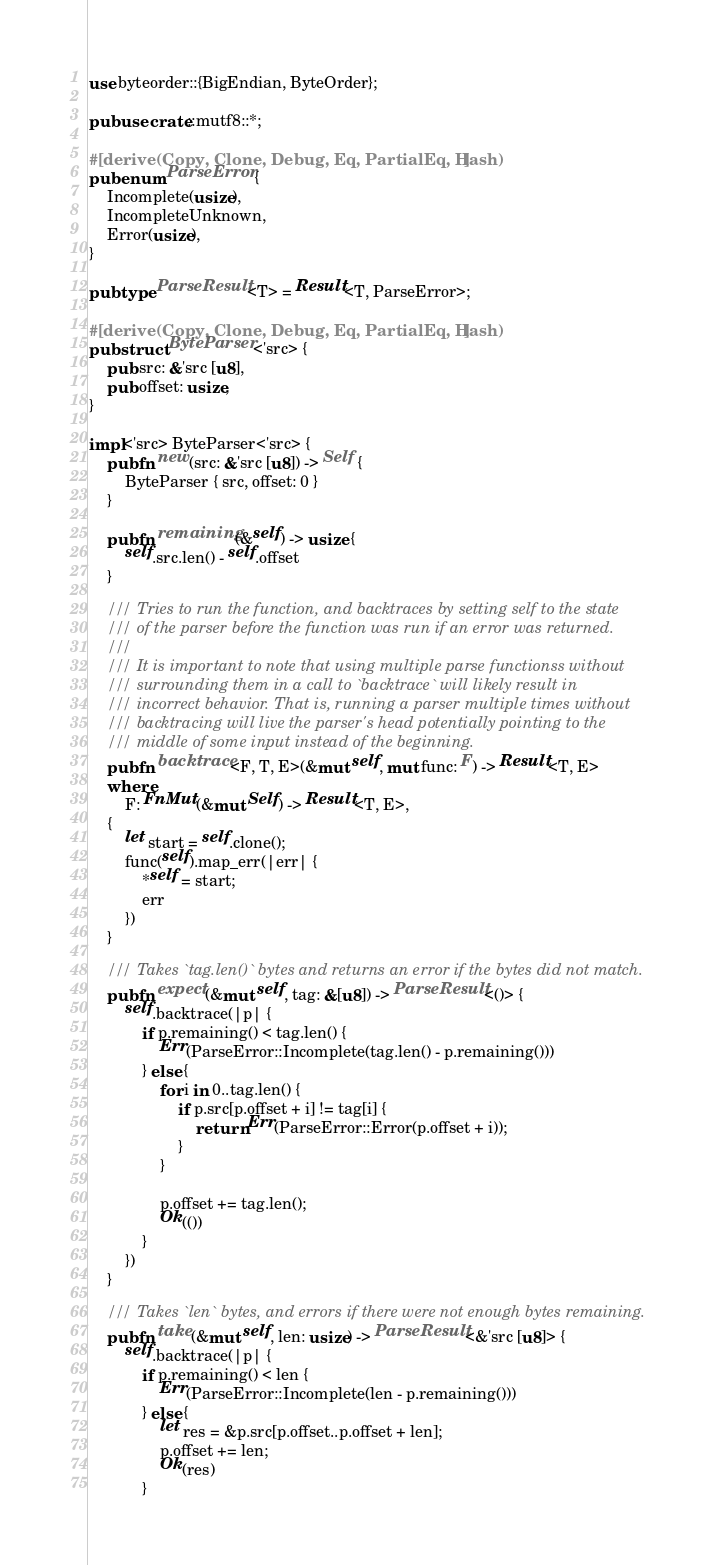<code> <loc_0><loc_0><loc_500><loc_500><_Rust_>use byteorder::{BigEndian, ByteOrder};

pub use crate::mutf8::*;

#[derive(Copy, Clone, Debug, Eq, PartialEq, Hash)]
pub enum ParseError {
    Incomplete(usize),
    IncompleteUnknown,
    Error(usize),
}

pub type ParseResult<T> = Result<T, ParseError>;

#[derive(Copy, Clone, Debug, Eq, PartialEq, Hash)]
pub struct ByteParser<'src> {
    pub src: &'src [u8],
    pub offset: usize,
}

impl<'src> ByteParser<'src> {
    pub fn new(src: &'src [u8]) -> Self {
        ByteParser { src, offset: 0 }
    }

    pub fn remaining(&self) -> usize {
        self.src.len() - self.offset
    }

    /// Tries to run the function, and backtraces by setting self to the state
    /// of the parser before the function was run if an error was returned.
    ///
    /// It is important to note that using multiple parse functionss without
    /// surrounding them in a call to `backtrace` will likely result in
    /// incorrect behavior. That is, running a parser multiple times without
    /// backtracing will live the parser's head potentially pointing to the
    /// middle of some input instead of the beginning.
    pub fn backtrace<F, T, E>(&mut self, mut func: F) -> Result<T, E>
    where
        F: FnMut(&mut Self) -> Result<T, E>,
    {
        let start = self.clone();
        func(self).map_err(|err| {
            *self = start;
            err
        })
    }

    /// Takes `tag.len()` bytes and returns an error if the bytes did not match.
    pub fn expect(&mut self, tag: &[u8]) -> ParseResult<()> {
        self.backtrace(|p| {
            if p.remaining() < tag.len() {
                Err(ParseError::Incomplete(tag.len() - p.remaining()))
            } else {
                for i in 0..tag.len() {
                    if p.src[p.offset + i] != tag[i] {
                        return Err(ParseError::Error(p.offset + i));
                    }
                }

                p.offset += tag.len();
                Ok(())
            }
        })
    }

    /// Takes `len` bytes, and errors if there were not enough bytes remaining.
    pub fn take(&mut self, len: usize) -> ParseResult<&'src [u8]> {
        self.backtrace(|p| {
            if p.remaining() < len {
                Err(ParseError::Incomplete(len - p.remaining()))
            } else {
                let res = &p.src[p.offset..p.offset + len];
                p.offset += len;
                Ok(res)
            }</code> 